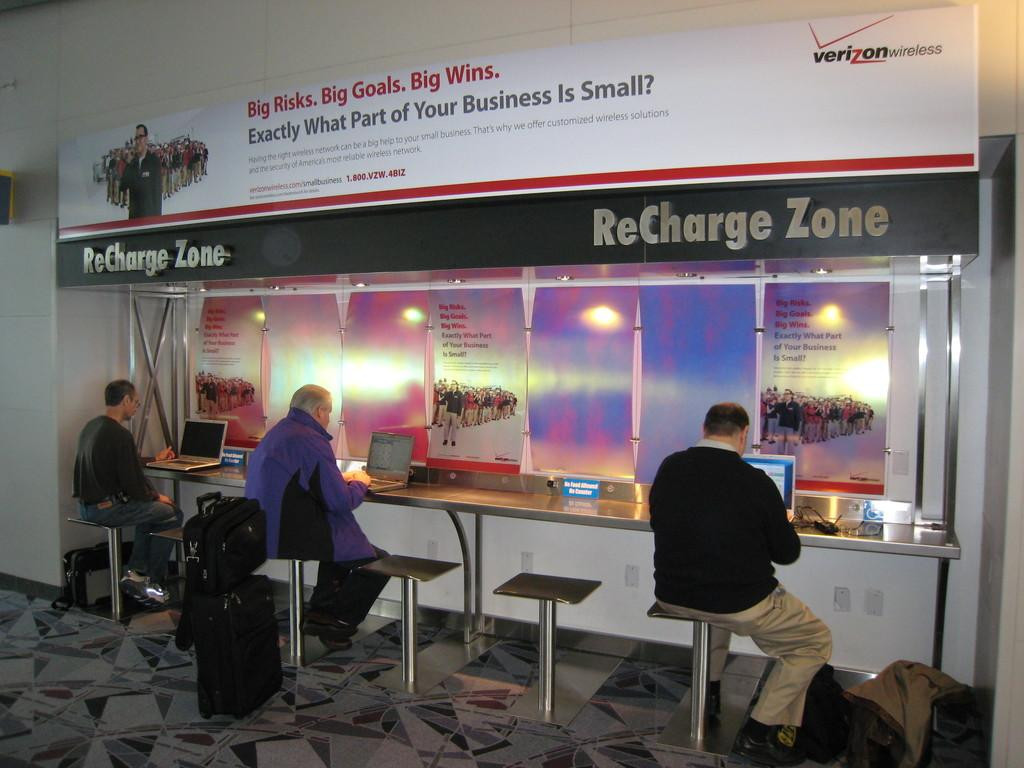<image>
Relay a brief, clear account of the picture shown. Three people sitting at a Verizon recharge zone with laptops. 